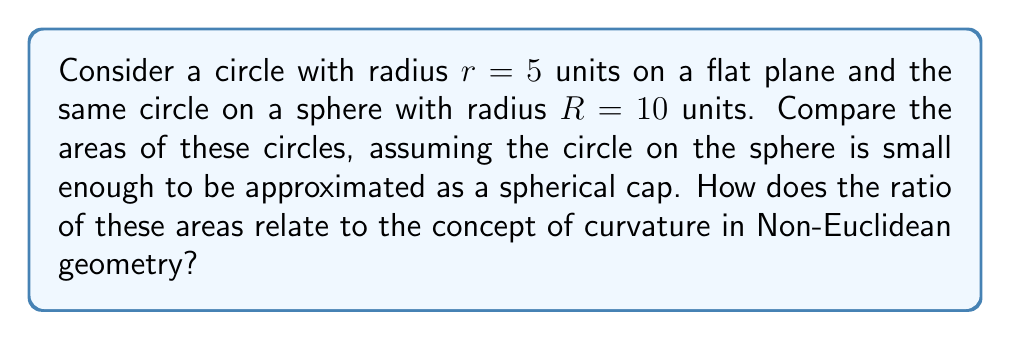Show me your answer to this math problem. 1. Area of a circle on a flat plane:
   $$A_{flat} = \pi r^2 = \pi (5)^2 = 25\pi$$

2. Area of a spherical cap (approximating the circle on the sphere):
   $$A_{sphere} = 2\pi R h$$
   where $h$ is the height of the spherical cap.

3. To find $h$, we use the Pythagorean theorem:
   $$R^2 = (R-h)^2 + r^2$$
   $$(10)^2 = (10-h)^2 + (5)^2$$
   $$100 = 100 - 20h + h^2 + 25$$
   $$h^2 - 20h - 25 = 0$$

4. Solving this quadratic equation:
   $$h \approx 1.3397$$

5. Now we can calculate the area on the sphere:
   $$A_{sphere} = 2\pi (10)(1.3397) \approx 84.1372$$

6. The ratio of the areas:
   $$\frac{A_{sphere}}{A_{flat}} = \frac{84.1372}{25\pi} \approx 1.0732$$

7. This ratio being greater than 1 indicates that the area on the sphere is slightly larger than on the flat plane, which is a consequence of positive curvature in spherical geometry.

8. In Non-Euclidean geometry, this difference in areas is related to the Gaussian curvature of the surface. The flat plane has zero curvature, while the sphere has positive constant curvature $K = \frac{1}{R^2}$.
Answer: The ratio of areas is approximately 1.0732, with the spherical area being larger due to positive curvature. 